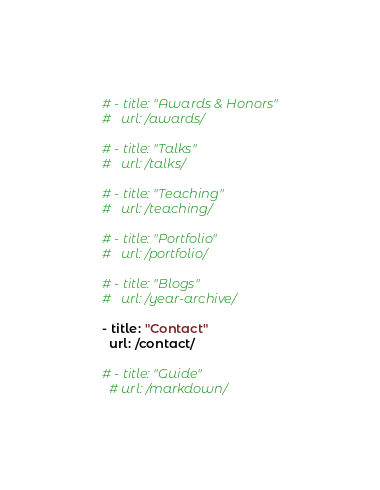<code> <loc_0><loc_0><loc_500><loc_500><_YAML_>
  # - title: "Awards & Honors"
  #   url: /awards/

  # - title: "Talks"
  #   url: /talks/    

  # - title: "Teaching"
  #   url: /teaching/    
    
  # - title: "Portfolio"
  #   url: /portfolio/
        
  # - title: "Blogs"
  #   url: /year-archive/
    
  - title: "Contact"
    url: /contact/  
    
  # - title: "Guide"
    # url: /markdown/
</code> 